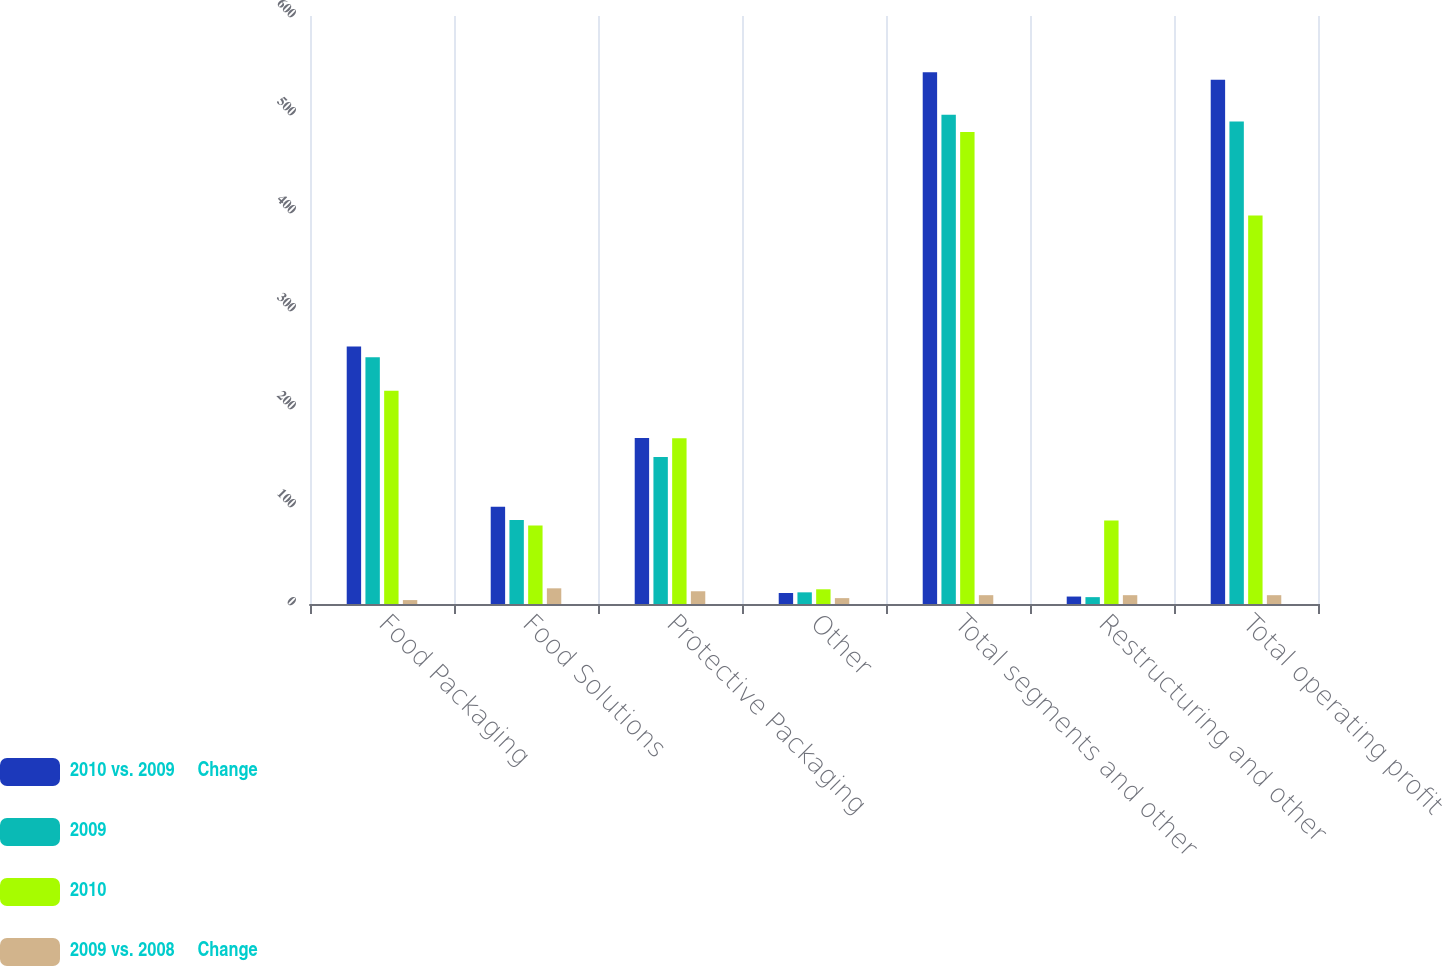Convert chart. <chart><loc_0><loc_0><loc_500><loc_500><stacked_bar_chart><ecel><fcel>Food Packaging<fcel>Food Solutions<fcel>Protective Packaging<fcel>Other<fcel>Total segments and other<fcel>Restructuring and other<fcel>Total operating profit<nl><fcel>2010 vs. 2009     Change<fcel>262.7<fcel>99.2<fcel>169.5<fcel>11.2<fcel>542.6<fcel>7.6<fcel>535<nl><fcel>2009<fcel>251.7<fcel>85.7<fcel>150<fcel>11.9<fcel>499.3<fcel>7<fcel>492.3<nl><fcel>2010<fcel>217.5<fcel>80<fcel>169.1<fcel>15<fcel>481.6<fcel>85.1<fcel>396.5<nl><fcel>2009 vs. 2008     Change<fcel>4<fcel>16<fcel>13<fcel>6<fcel>9<fcel>9<fcel>9<nl></chart> 